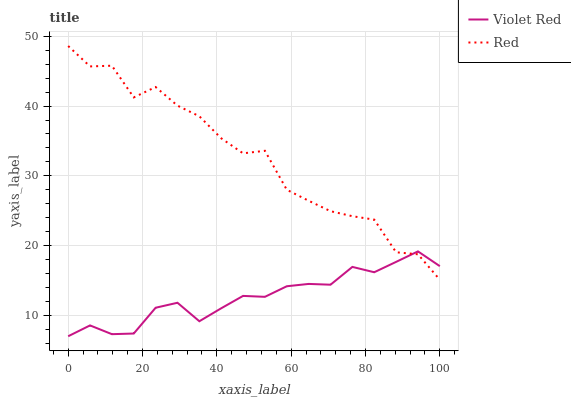Does Red have the minimum area under the curve?
Answer yes or no. No. Is Red the smoothest?
Answer yes or no. No. Does Red have the lowest value?
Answer yes or no. No. 